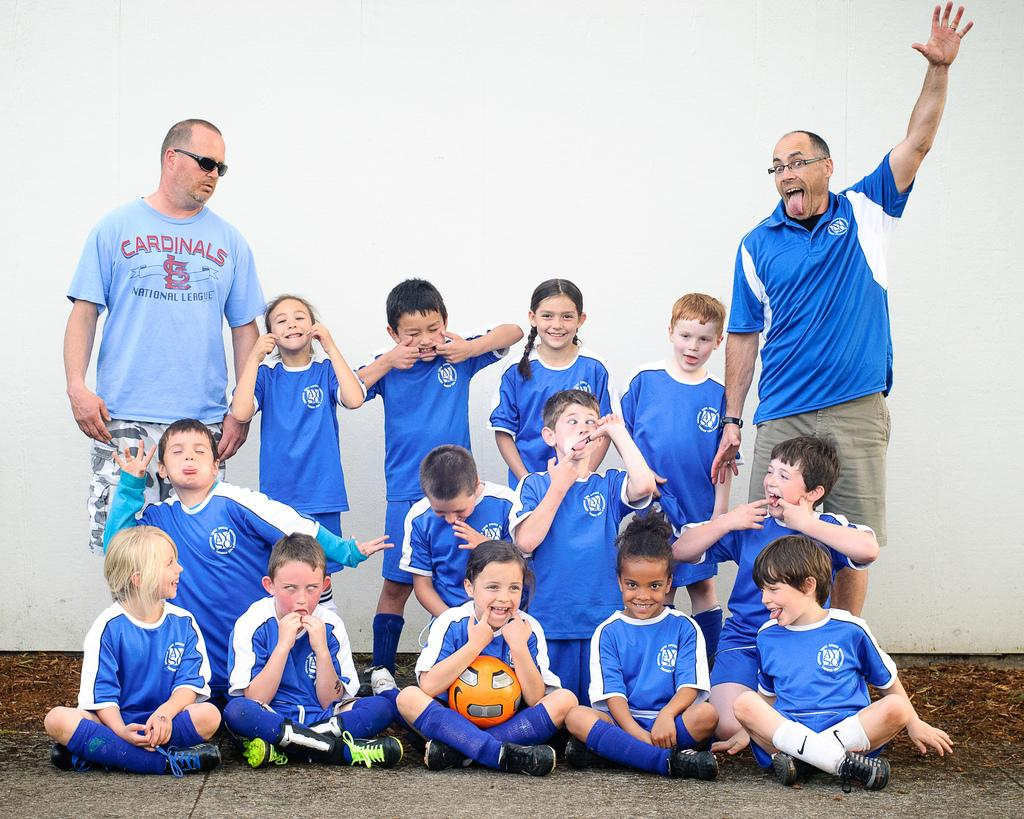What are the people in the image doing? Some people are standing, and some are sitting in the image. What object can be seen in the image? There is a ball in the image. What is the surface beneath the people in the image? The bottom of the image contains a floor. What can be seen in the background of the image? There is a wall in the background of the image. What type of joke is being told by the band in the image? There is no band present in the image, and therefore no jokes are being told. Can you hear the whistle of the people in the image? There is no mention of a whistle in the image, so it cannot be heard. 